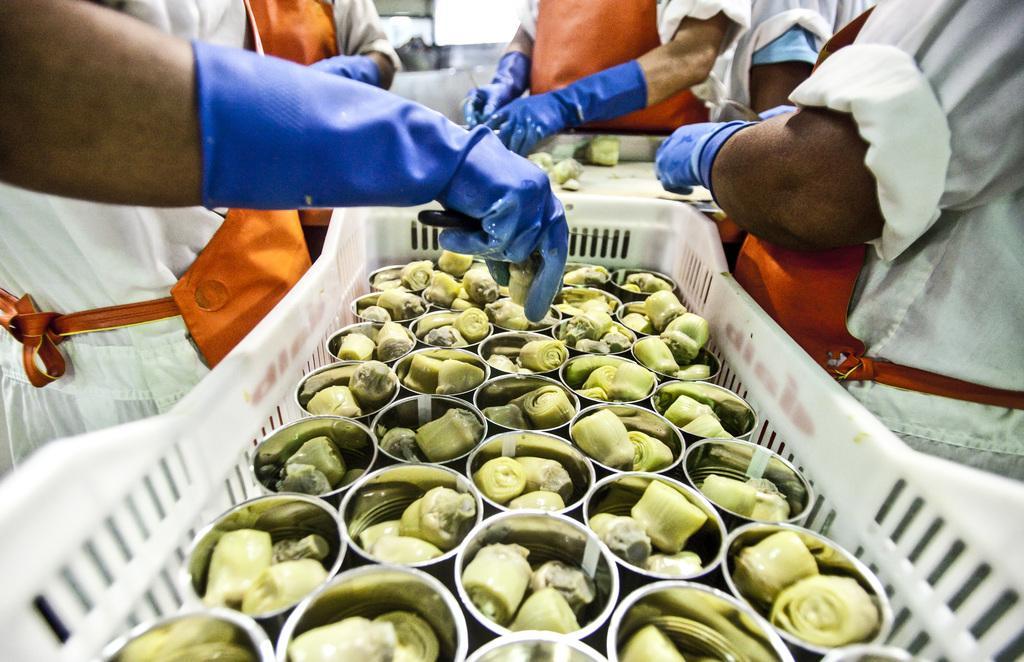Could you give a brief overview of what you see in this image? In this picture I can observe some food places in the small bowls. These bowls are placed in the white color tray. Some people are standing around this tray. They are wearing blue color gloves and an orange color aprons. 